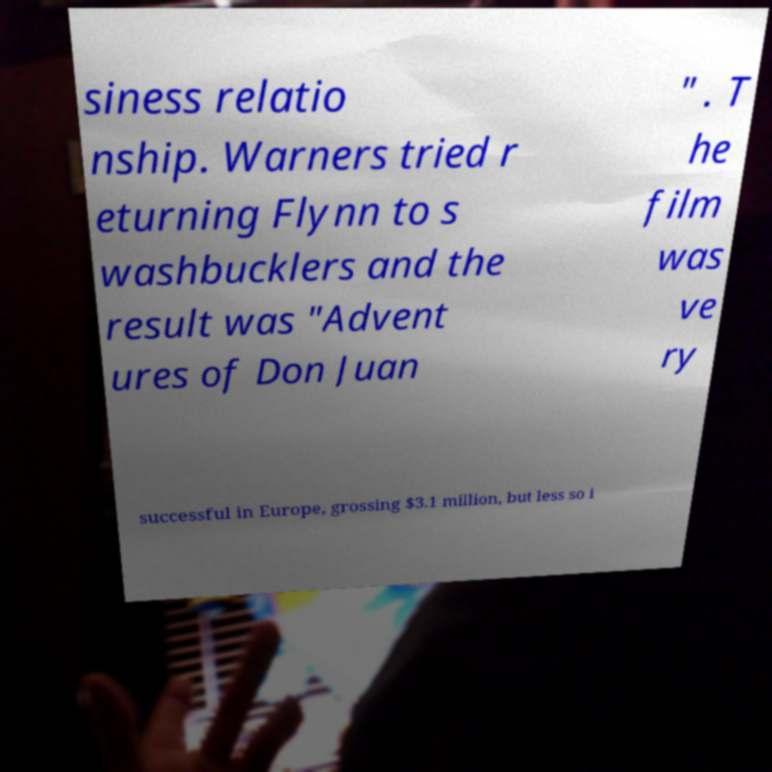Could you assist in decoding the text presented in this image and type it out clearly? siness relatio nship. Warners tried r eturning Flynn to s washbucklers and the result was "Advent ures of Don Juan " . T he film was ve ry successful in Europe, grossing $3.1 million, but less so i 